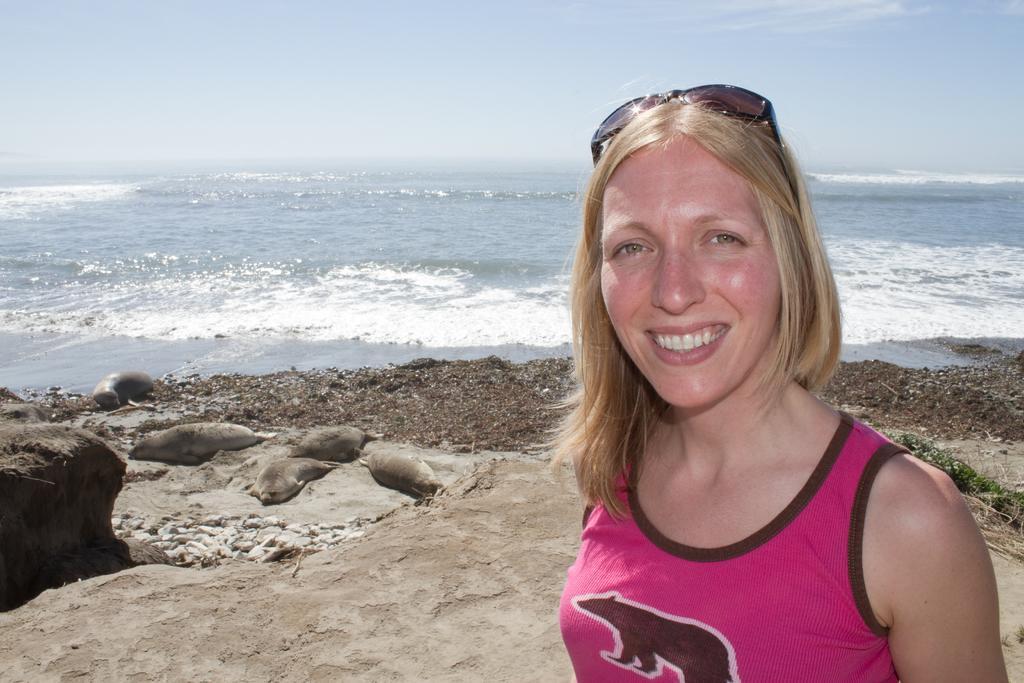Could you give a brief overview of what you see in this image? This picture might be taken on the sea shore. In this image, on the right side, we can see a woman wearing pink color shirt. On the left side, we can see some sea mammals. In the background, we can see water in an ocean. At the top, we can see a sky which is a bit cloudy, at the bottom, we can see some sand and some stones. 